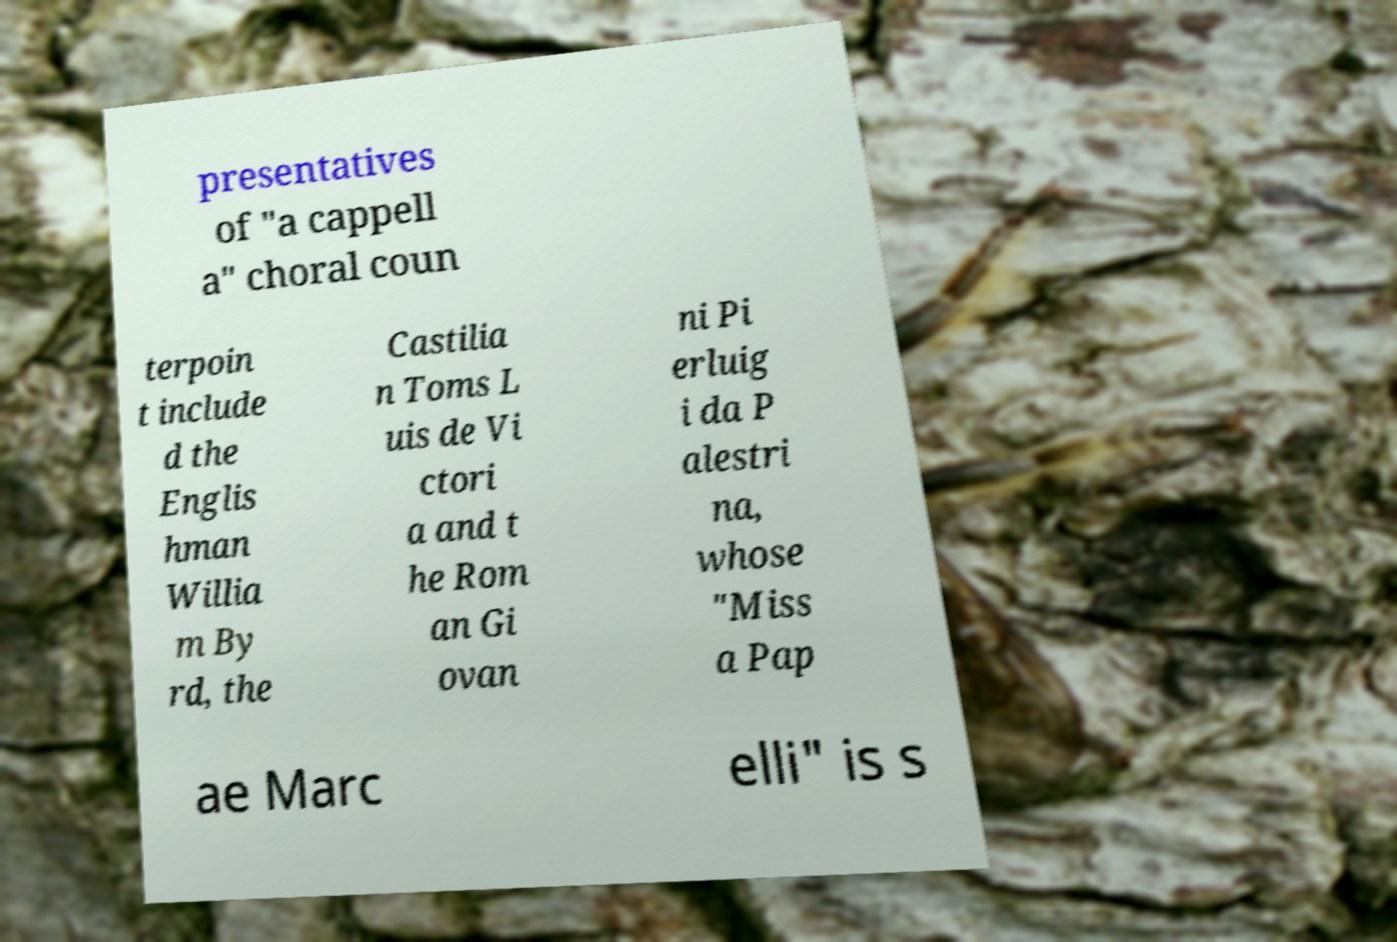Please read and relay the text visible in this image. What does it say? presentatives of "a cappell a" choral coun terpoin t include d the Englis hman Willia m By rd, the Castilia n Toms L uis de Vi ctori a and t he Rom an Gi ovan ni Pi erluig i da P alestri na, whose "Miss a Pap ae Marc elli" is s 